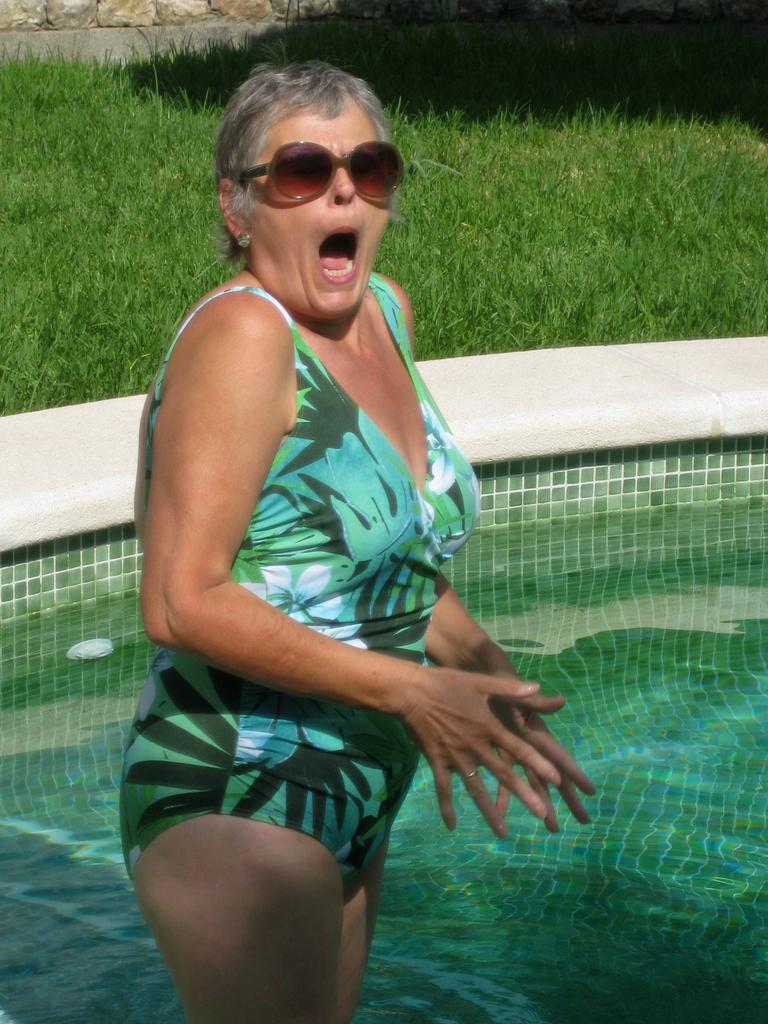What is the woman in the image wearing? There is a woman in a bikini in the image. What is the woman doing with her mouth? The woman has her mouth open in the image. Where is the woman standing? The woman is standing on a floor in the image. What is the location of the floor in relation to the swimming pool? The floor is near a swimming pool in the image. What type of vegetation can be seen in the background? There is grass on the ground in the background of the image. What type of natural feature is arranged in the background? Rocks are arranged in the background of the image. What is the queen doing in the image? There is no queen present in the image; it features a woman in a bikini. What type of knee injury is visible in the image? There is no knee injury present in the image; the woman's knees are not visible. 